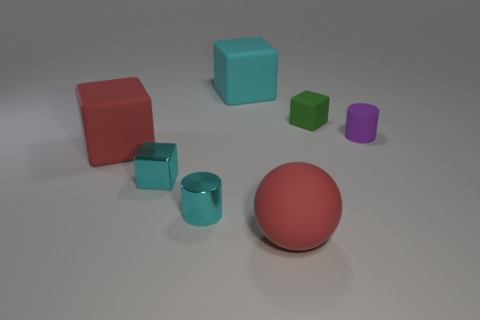Subtract all red cubes. How many cubes are left? 3 Subtract all tiny matte blocks. How many blocks are left? 3 Subtract all cyan cylinders. How many cyan cubes are left? 2 Add 3 matte spheres. How many objects exist? 10 Subtract all cylinders. How many objects are left? 5 Subtract all brown cylinders. Subtract all cyan balls. How many cylinders are left? 2 Subtract all cyan objects. Subtract all large red matte spheres. How many objects are left? 3 Add 1 tiny objects. How many tiny objects are left? 5 Add 5 tiny cyan shiny balls. How many tiny cyan shiny balls exist? 5 Subtract 1 red cubes. How many objects are left? 6 